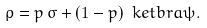<formula> <loc_0><loc_0><loc_500><loc_500>\rho = p \, \sigma + ( 1 - p ) \ k e t b r a { \psi } .</formula> 